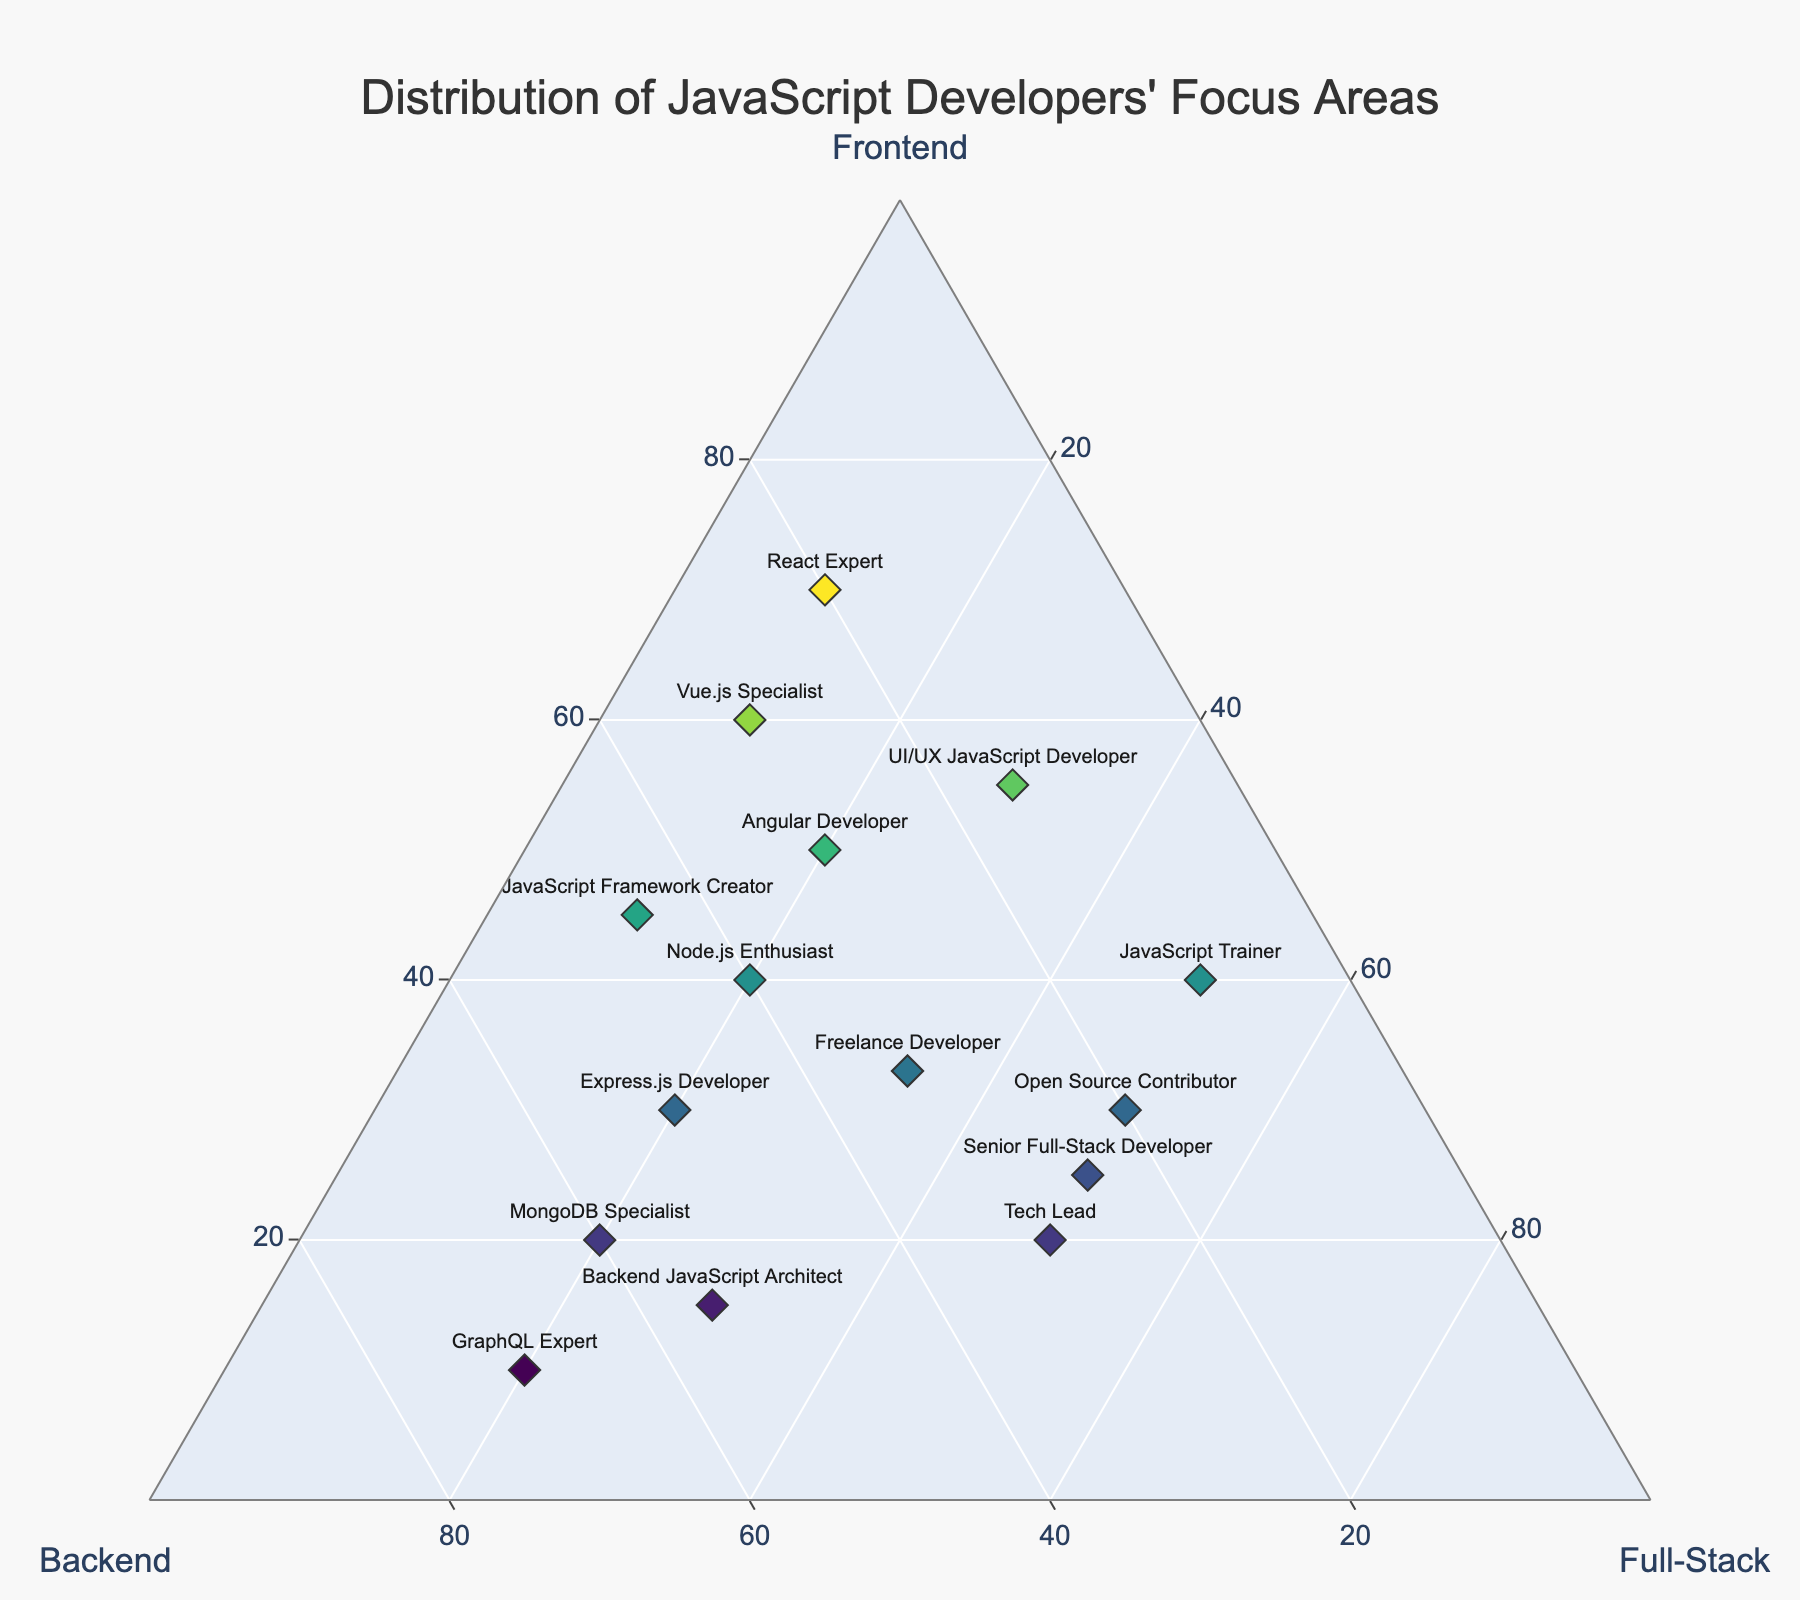What's the title of the figure? The title is prominently displayed at the top of the figure. The specific wording of the title describes the main content of the ternary plot.
Answer: Distribution of JavaScript Developers' Focus Areas How many developers in total are represented on the plot? Count the number of points or markers on the plot, each representing one developer.
Answer: 15 Which developer has the highest focus on frontend development? Look for the marker closest to the ‘Frontend’ vertex of the ternary plot. This indicates the highest percentage in that category.
Answer: React Expert Which developer has the most balanced focus between frontend, backend, and full-stack development? Find the developer whose marker is closest to the center of the ternary plot, suggesting an even distribution across all areas.
Answer: Freelance Developer What's the combined frontend focus of the React Expert and Vue.js Specialist? Add the frontend percentages for React Expert and Vue.js Specialist: 70% and 60%.
Answer: 130% Which developer has a higher backend focus, Node.js Enthusiast or Express.js Developer? Compare the backend percentages for both developers: Node.js Enthusiast (40%) and Express.js Developer (50%).
Answer: Express.js Developer Which development focus is the least common among all developers? Identify the vertex (Frontend, Backend, or Full-Stack) with the fewest number of close markers or the lowest cumulative percentages.
Answer: Full-Stack What is the full-stack development percentage of the JavaScript Trainer? Check the marker corresponding to JavaScript Trainer and note its position relative to the Full-Stack vertex.
Answer: 50% What trend can you observe among developers with a backend focus higher than 50%? Identify the markers with a backend percentage greater than 50% and describe any common patterns or distributions among them.
Answer: They tend to have a moderate full-stack focus and low frontend focus How does the Angular Developer’s focus differ from that of the MongoDB Specialist? Compare the percentages of frontend, backend, and full-stack focuses for both developers. Angular Developer: 50% frontend, 30% backend, 20% full-stack. MongoDB Specialist: 20% frontend, 60% backend, 20% full-stack.
Answer: Angular Developer has a higher frontend focus, MongoDB Specialist has a higher backend focus, both have the same full-stack focus 